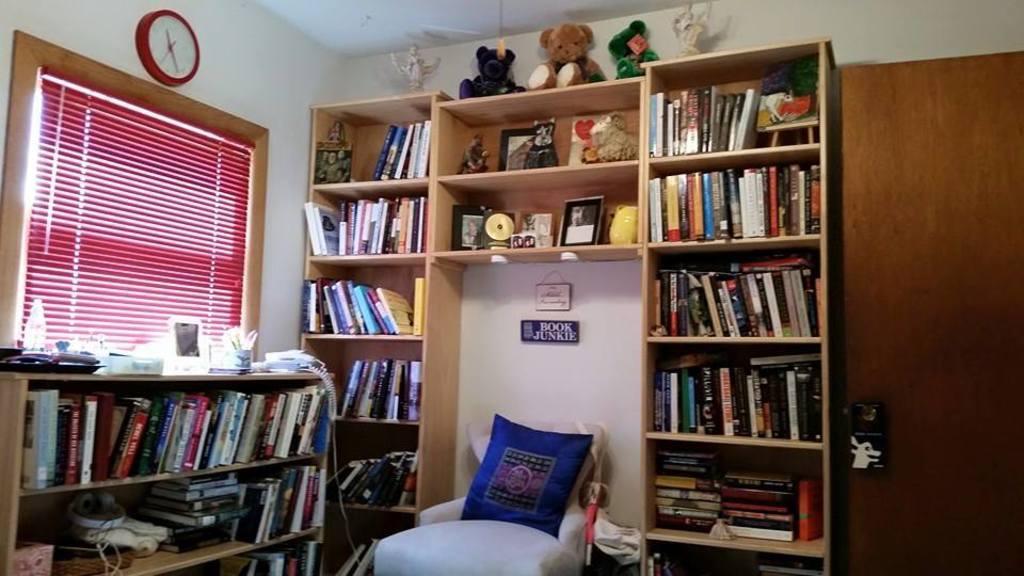Please provide a concise description of this image. In the image there is a chair and around the chair there are many shelves, in the shelves there are a lot of books and frames and other toys are kept, on the right side there is a door and on the left side there is a blind in front of the window, above the window there is a clock fit to the wall. 